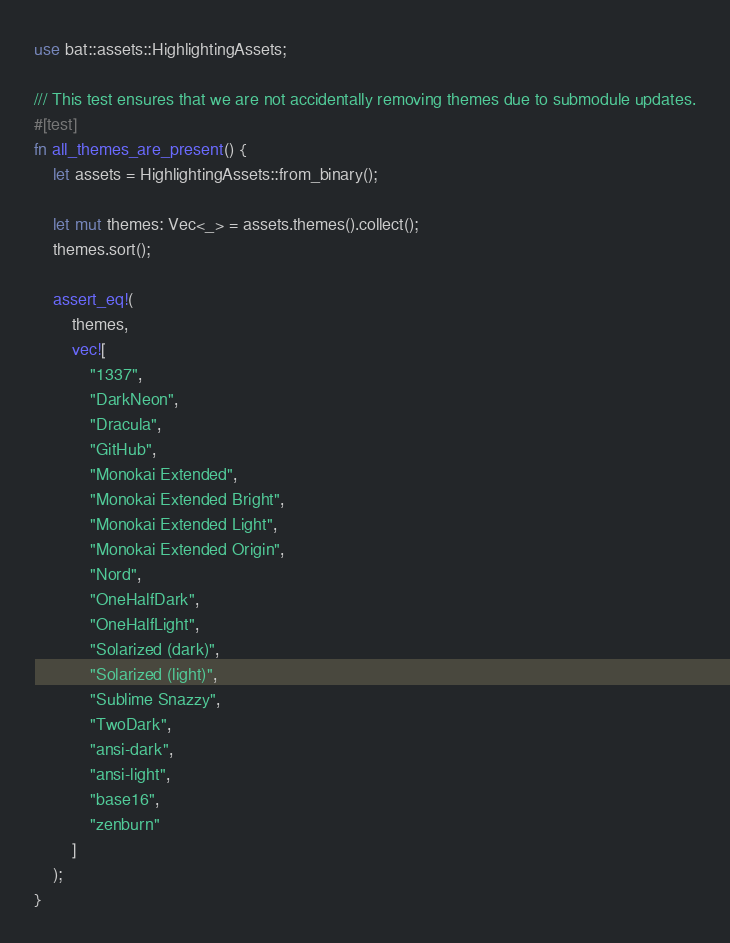<code> <loc_0><loc_0><loc_500><loc_500><_Rust_>use bat::assets::HighlightingAssets;

/// This test ensures that we are not accidentally removing themes due to submodule updates.
#[test]
fn all_themes_are_present() {
    let assets = HighlightingAssets::from_binary();

    let mut themes: Vec<_> = assets.themes().collect();
    themes.sort();

    assert_eq!(
        themes,
        vec![
            "1337",
            "DarkNeon",
            "Dracula",
            "GitHub",
            "Monokai Extended",
            "Monokai Extended Bright",
            "Monokai Extended Light",
            "Monokai Extended Origin",
            "Nord",
            "OneHalfDark",
            "OneHalfLight",
            "Solarized (dark)",
            "Solarized (light)",
            "Sublime Snazzy",
            "TwoDark",
            "ansi-dark",
            "ansi-light",
            "base16",
            "zenburn"
        ]
    );
}
</code> 